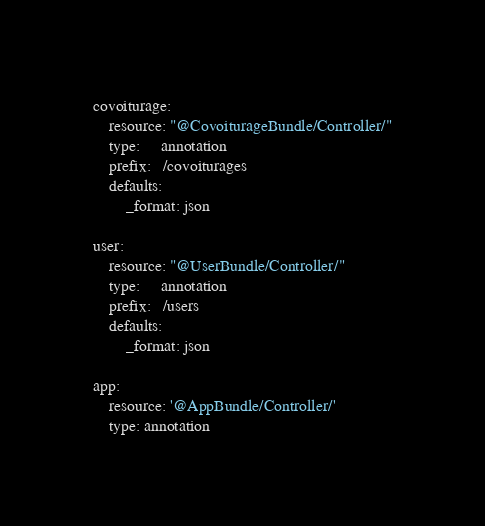<code> <loc_0><loc_0><loc_500><loc_500><_YAML_>covoiturage:
    resource: "@CovoiturageBundle/Controller/"
    type:     annotation
    prefix:   /covoiturages
    defaults:
        _format: json

user:
    resource: "@UserBundle/Controller/"
    type:     annotation
    prefix:   /users
    defaults:
        _format: json

app:
    resource: '@AppBundle/Controller/'
    type: annotation
</code> 